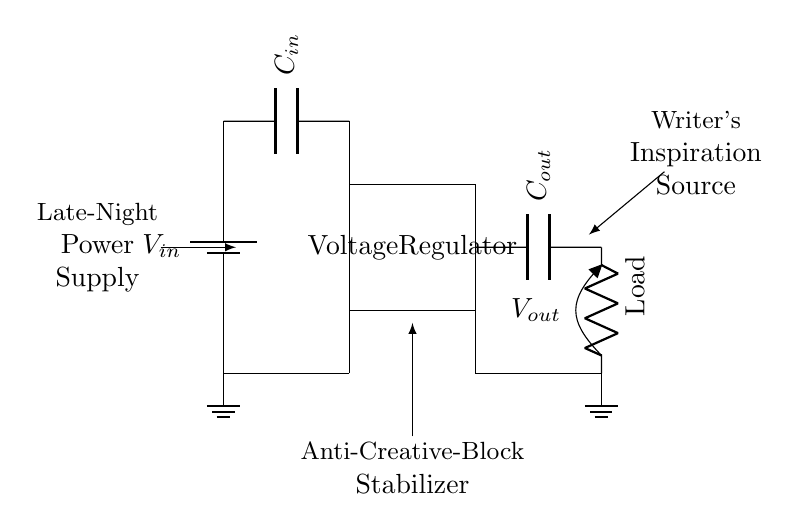What is the main component in this circuit? The main component is the voltage regulator, indicated by the rectangle labeled "Voltage Regulator." It is responsible for converting the input voltage to a stable output voltage.
Answer: Voltage Regulator What does C_in represent? C_in is the input capacitor, which stabilizes the input voltage supplied to the voltage regulator. It helps filter out noise and smooths the input current fluctuations.
Answer: Input capacitor What is the purpose of C_out? C_out is the output capacitor, which ensures that the output voltage remains stable and reduces voltage fluctuations during transient loads or changes in current draw by the load.
Answer: Output capacitor How many grounds are shown in the circuit? There are two ground symbols shown, one at the input and one at the output side of the circuit, which represent the common reference point for both parts of the circuit.
Answer: Two What is the load type in this circuit? The load is indicated by a resistor symbol labeled "Load," which represents the component or device powered by the regulated voltage output.
Answer: Resistor What is the significance of labeling as "Writer's Inspiration Source"? This humorous label indicates that the voltage regulator keeps the writer's laptop powered during brainstorming, suggesting that consistent power is crucial for creativity, especially during late-night sessions.
Answer: Creative motivation What does the circuit do during late-night brainstorming? The circuit maintains a consistent output voltage to the laptop, preventing power fluctuations that could interrupt the writer's thought process, thus avoiding disruptions to their late-night creativity flow.
Answer: Maintains voltage 